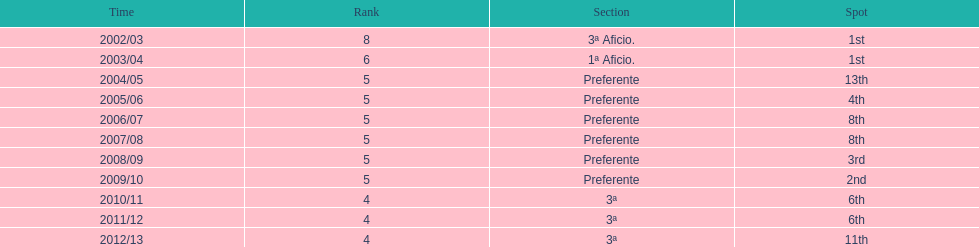What was the number of wins for preferente? 6. 